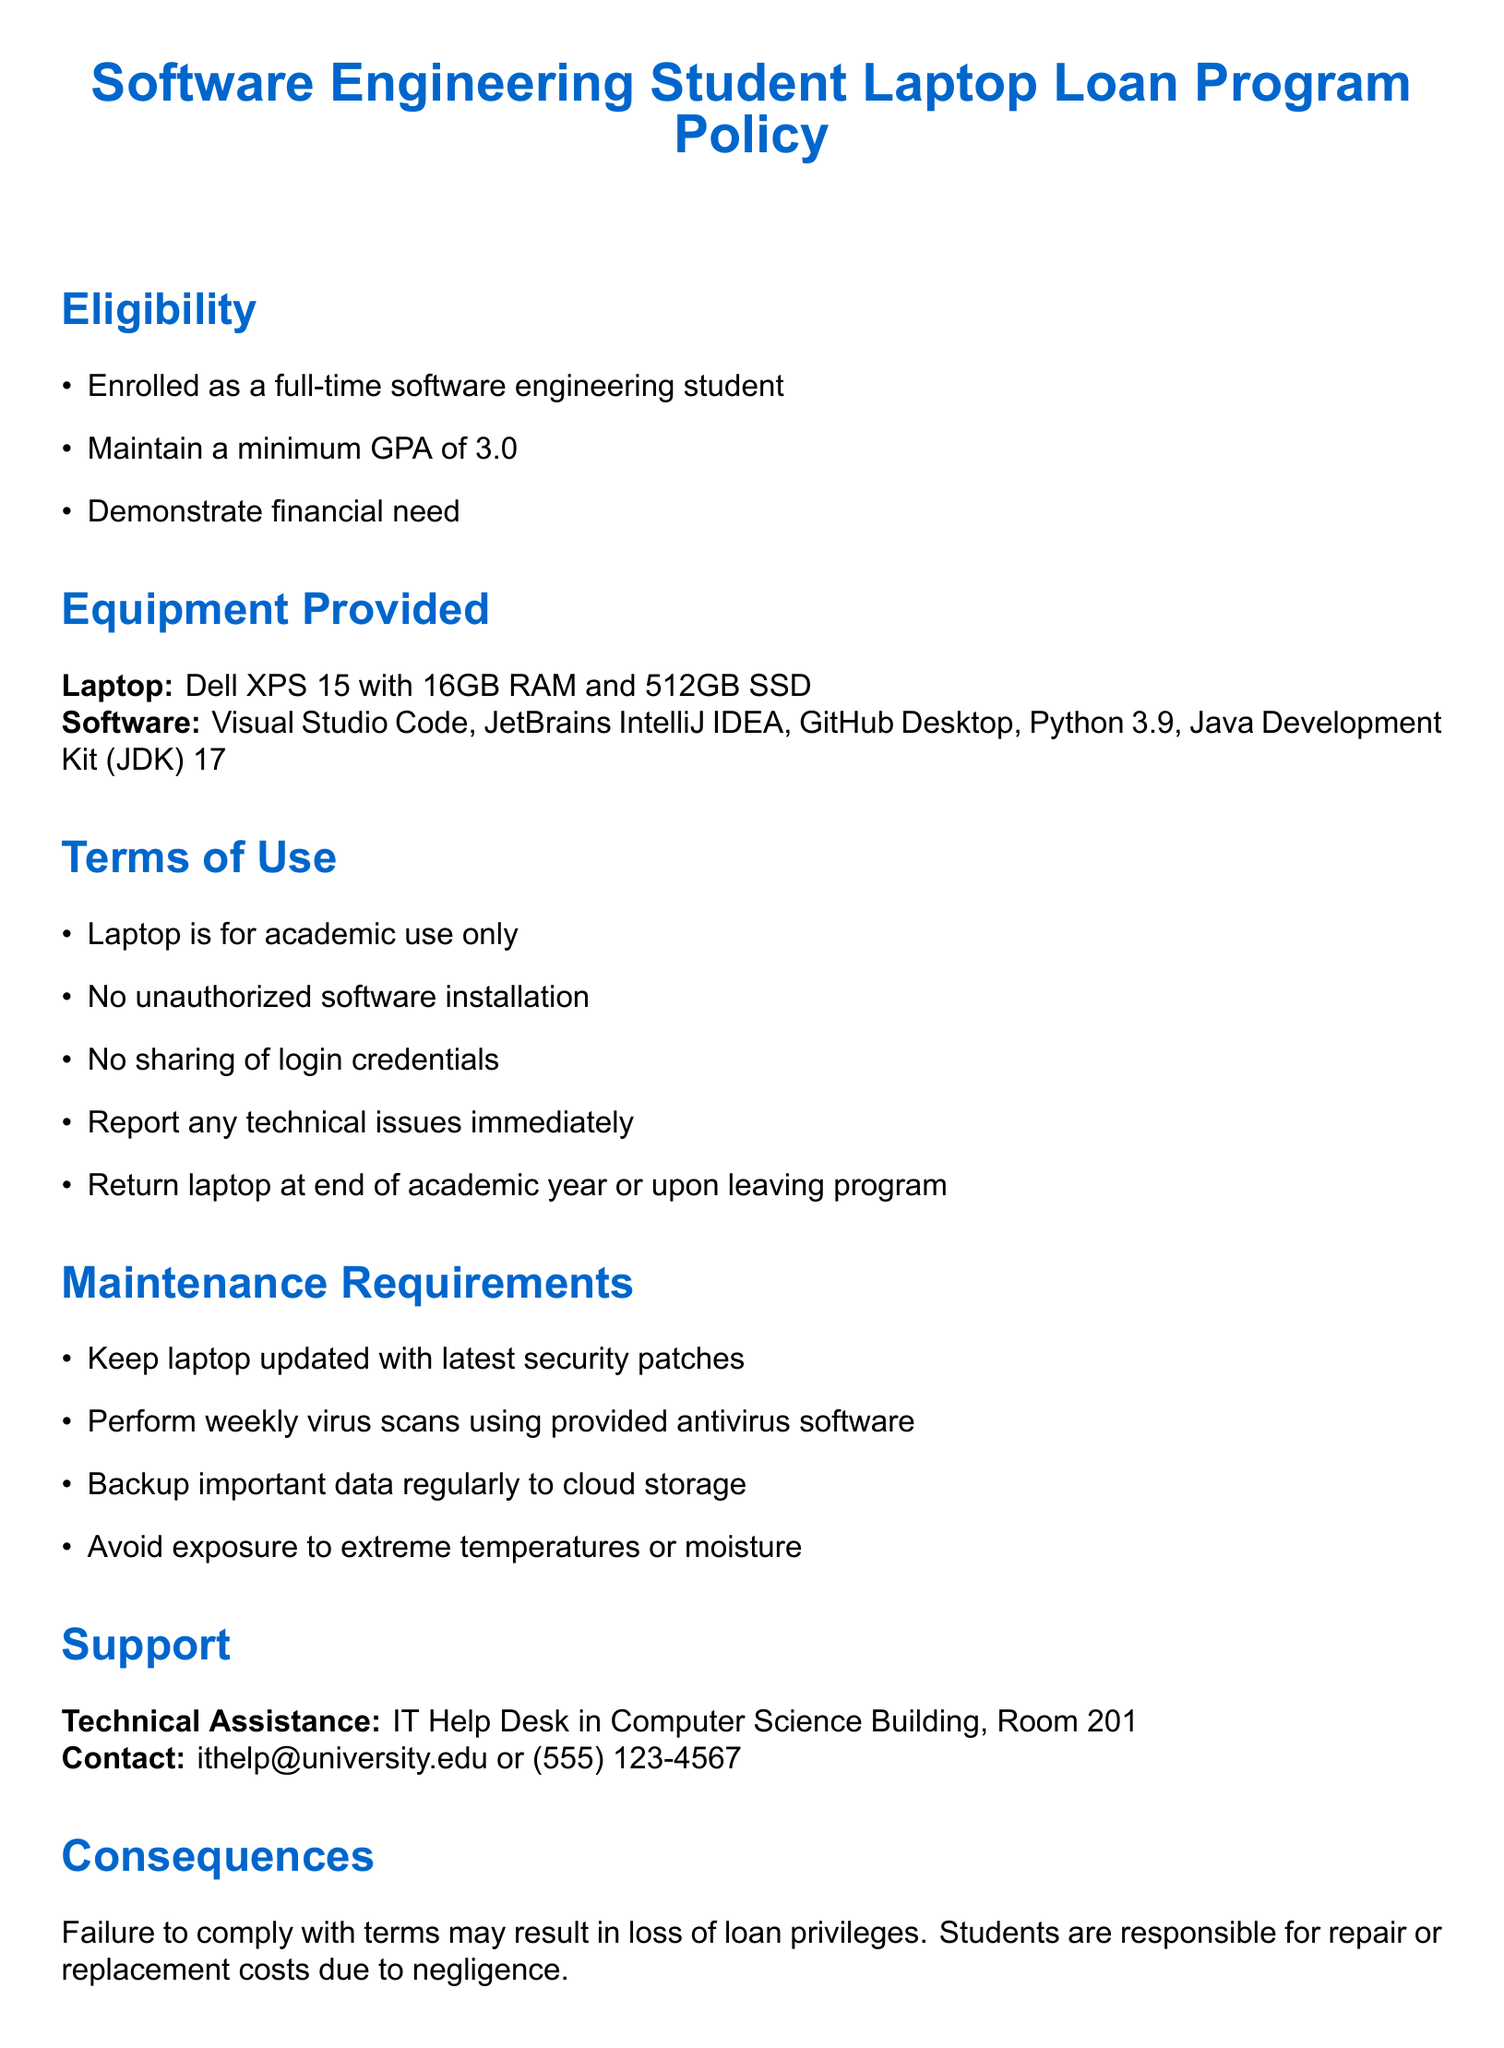What is the minimum GPA required for eligibility? The document specifies that students must maintain a minimum GPA of 3.0 in order to be eligible for the laptop loan program.
Answer: 3.0 What is the laptop model provided? The policy document states that the laptop provided is a Dell XPS 15.
Answer: Dell XPS 15 What software is included with the laptop? The document lists software provided with the laptop, which includes Visual Studio Code, JetBrains IntelliJ IDEA, GitHub Desktop, Python 3.9, and Java Development Kit (JDK) 17.
Answer: Visual Studio Code, JetBrains IntelliJ IDEA, GitHub Desktop, Python 3.9, JDK 17 What should students do if they encounter technical issues? The document instructs students to report any technical issues immediately if they arise with their laptops.
Answer: Report immediately Where is technical assistance available? The document indicates that technical assistance is available at the IT Help Desk located in the Computer Science Building, Room 201.
Answer: IT Help Desk, Room 201 What is the deadline for returning the laptop? According to the policy, students must return the laptop by the last day of spring semester final exams.
Answer: Last day of spring semester final exams What happens if a student fails to comply with the terms? The policy states that failure to comply may result in the loss of loan privileges for the student.
Answer: Loss of loan privileges What is the loan duration for the laptop? The document specifies that the loan duration for the laptop is one academic year, which is renewable annually.
Answer: One academic year 